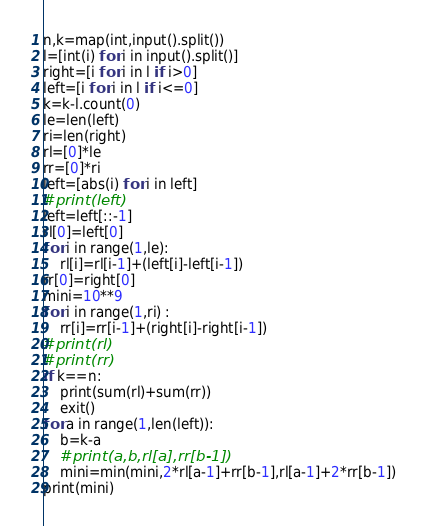<code> <loc_0><loc_0><loc_500><loc_500><_Python_>n,k=map(int,input().split())
l=[int(i) for i in input().split()]
right=[i for i in l if i>0]
left=[i for i in l if i<=0]
k=k-l.count(0)
le=len(left)
ri=len(right)
rl=[0]*le 
rr=[0]*ri 
left=[abs(i) for i in left]
#print(left)
left=left[::-1]
rl[0]=left[0]
for i in range(1,le):
    rl[i]=rl[i-1]+(left[i]-left[i-1])
rr[0]=right[0]
mini=10**9 
for i in range(1,ri) :
    rr[i]=rr[i-1]+(right[i]-right[i-1])
#print(rl)
#print(rr)
if k==n:
    print(sum(rl)+sum(rr))
    exit()
for a in range(1,len(left)):
    b=k-a 
    #print(a,b,rl[a],rr[b-1])
    mini=min(mini,2*rl[a-1]+rr[b-1],rl[a-1]+2*rr[b-1])
print(mini)</code> 